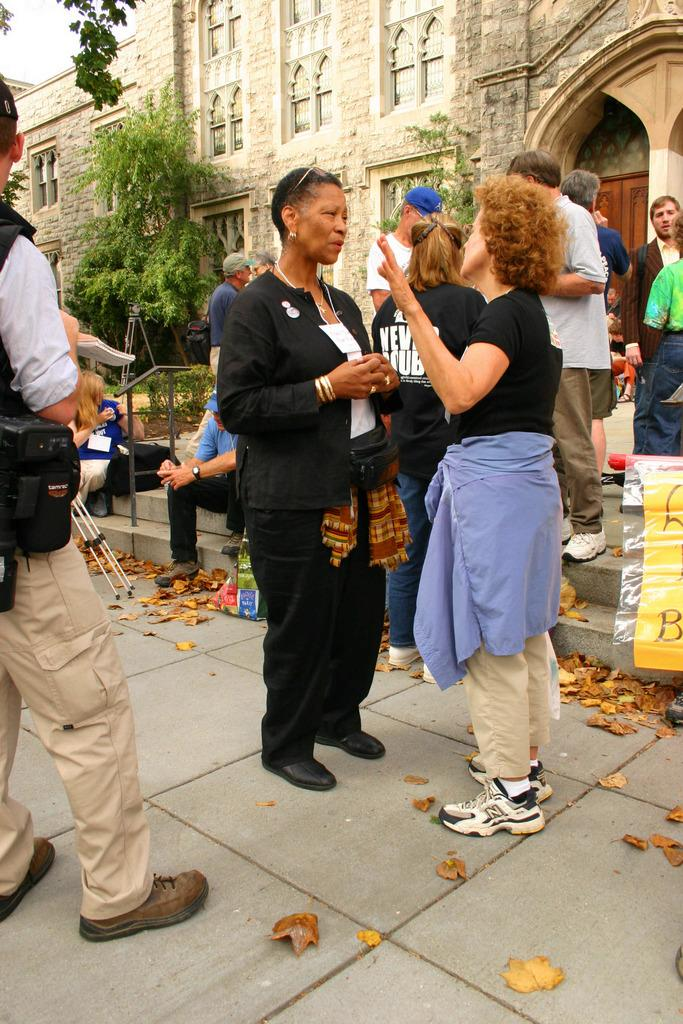Who or what can be seen in the image? There are people in the image. What is visible in the background of the image? There is a building and trees in the background of the image. What might indicate the season or weather in the image? The presence of dry leaves on the floor suggests that it is autumn or a dry season. What is the annual profit of the company depicted in the image? There is no information about a company or its profit in the image. 